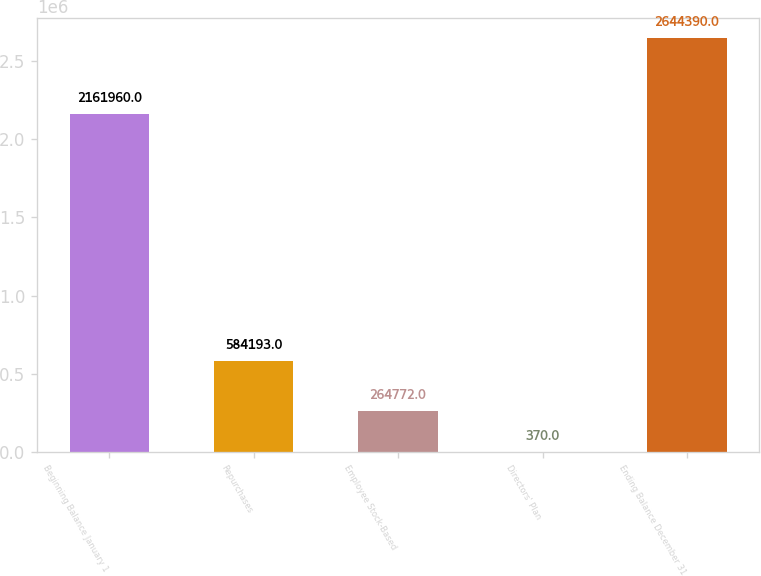Convert chart. <chart><loc_0><loc_0><loc_500><loc_500><bar_chart><fcel>Beginning Balance January 1<fcel>Repurchases<fcel>Employee Stock-Based<fcel>Directors' Plan<fcel>Ending Balance December 31<nl><fcel>2.16196e+06<fcel>584193<fcel>264772<fcel>370<fcel>2.64439e+06<nl></chart> 